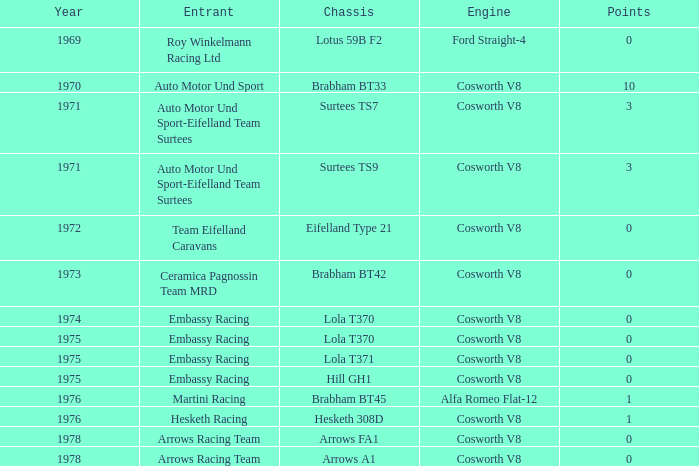In 1970, what entrant had a cosworth v8 engine? Auto Motor Und Sport. 